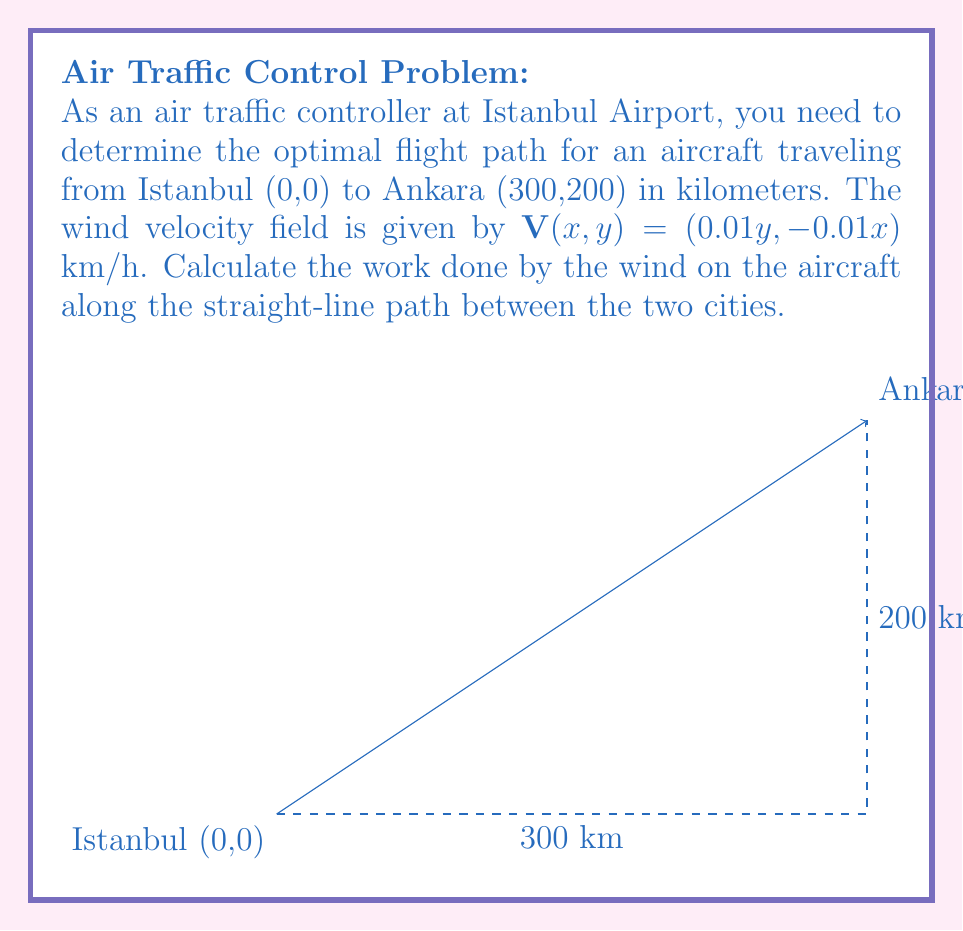Could you help me with this problem? To solve this problem, we need to evaluate the line integral of the wind velocity field along the straight-line path from Istanbul to Ankara. Let's follow these steps:

1) The parametric equations for the straight-line path from (0,0) to (300,200) are:
   $x(t) = 300t$, $y(t) = 200t$, where $0 \leq t \leq 1$

2) The velocity vector of the aircraft along this path is:
   $\mathbf{r}'(t) = (300, 200)$

3) The wind velocity field is:
   $\mathbf{V}(x,y) = (0.01y, -0.01x)$

4) Along the path, this becomes:
   $\mathbf{V}(t) = (0.01(200t), -0.01(300t)) = (2t, -3t)$

5) The work done is given by the line integral:
   $$W = \int_C \mathbf{V} \cdot d\mathbf{r} = \int_0^1 \mathbf{V}(t) \cdot \mathbf{r}'(t) dt$$

6) Calculating the dot product:
   $\mathbf{V}(t) \cdot \mathbf{r}'(t) = (2t, -3t) \cdot (300, 200) = 600t - 600t = 0$

7) Therefore, the integral becomes:
   $$W = \int_0^1 0 dt = 0$$

The work done by the wind on the aircraft along this path is zero. This means that the wind's effect on the aircraft's energy balances out over the course of the journey.
Answer: 0 km⋅km/h 